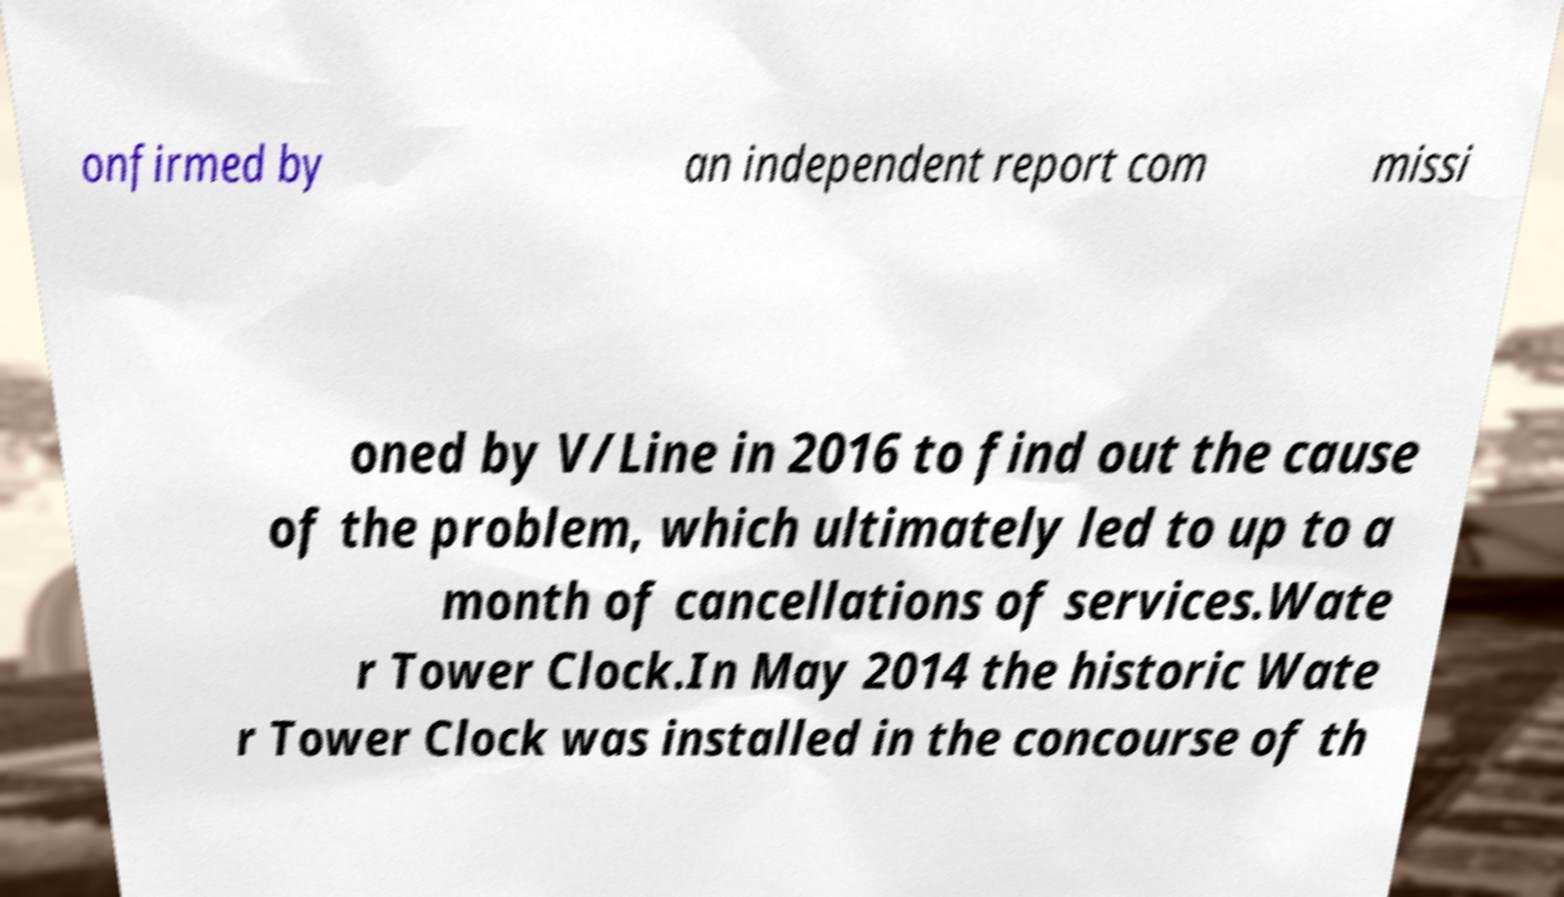What messages or text are displayed in this image? I need them in a readable, typed format. onfirmed by an independent report com missi oned by V/Line in 2016 to find out the cause of the problem, which ultimately led to up to a month of cancellations of services.Wate r Tower Clock.In May 2014 the historic Wate r Tower Clock was installed in the concourse of th 